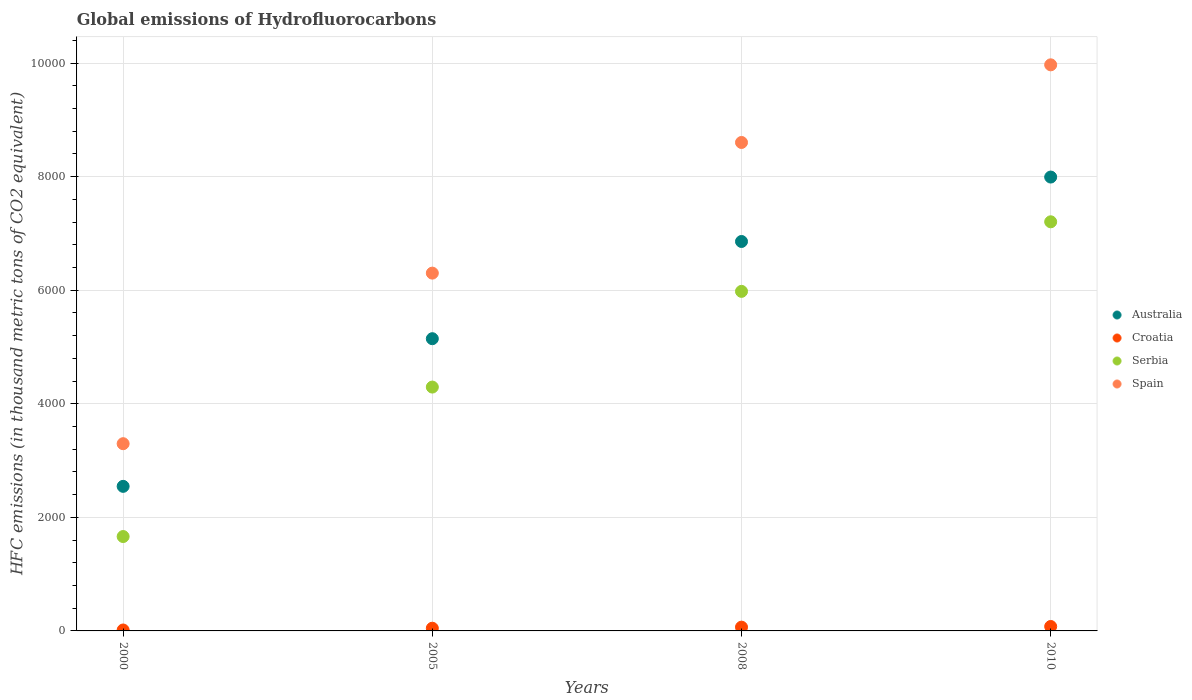Is the number of dotlines equal to the number of legend labels?
Your answer should be compact. Yes. Across all years, what is the minimum global emissions of Hydrofluorocarbons in Spain?
Make the answer very short. 3296.8. In which year was the global emissions of Hydrofluorocarbons in Spain maximum?
Ensure brevity in your answer.  2010. In which year was the global emissions of Hydrofluorocarbons in Croatia minimum?
Keep it short and to the point. 2000. What is the total global emissions of Hydrofluorocarbons in Australia in the graph?
Offer a terse response. 2.25e+04. What is the difference between the global emissions of Hydrofluorocarbons in Spain in 2000 and that in 2010?
Make the answer very short. -6671.2. What is the difference between the global emissions of Hydrofluorocarbons in Serbia in 2000 and the global emissions of Hydrofluorocarbons in Croatia in 2005?
Offer a very short reply. 1614.5. What is the average global emissions of Hydrofluorocarbons in Croatia per year?
Provide a short and direct response. 52.02. In the year 2000, what is the difference between the global emissions of Hydrofluorocarbons in Australia and global emissions of Hydrofluorocarbons in Croatia?
Offer a very short reply. 2529.4. In how many years, is the global emissions of Hydrofluorocarbons in Spain greater than 2400 thousand metric tons?
Give a very brief answer. 4. What is the ratio of the global emissions of Hydrofluorocarbons in Australia in 2008 to that in 2010?
Give a very brief answer. 0.86. Is the difference between the global emissions of Hydrofluorocarbons in Australia in 2008 and 2010 greater than the difference between the global emissions of Hydrofluorocarbons in Croatia in 2008 and 2010?
Your response must be concise. No. What is the difference between the highest and the second highest global emissions of Hydrofluorocarbons in Croatia?
Your answer should be compact. 11.7. What is the difference between the highest and the lowest global emissions of Hydrofluorocarbons in Serbia?
Provide a short and direct response. 5542. In how many years, is the global emissions of Hydrofluorocarbons in Croatia greater than the average global emissions of Hydrofluorocarbons in Croatia taken over all years?
Provide a short and direct response. 2. Is the sum of the global emissions of Hydrofluorocarbons in Australia in 2005 and 2008 greater than the maximum global emissions of Hydrofluorocarbons in Croatia across all years?
Your response must be concise. Yes. Is it the case that in every year, the sum of the global emissions of Hydrofluorocarbons in Serbia and global emissions of Hydrofluorocarbons in Spain  is greater than the sum of global emissions of Hydrofluorocarbons in Croatia and global emissions of Hydrofluorocarbons in Australia?
Your answer should be compact. Yes. Is the global emissions of Hydrofluorocarbons in Serbia strictly less than the global emissions of Hydrofluorocarbons in Croatia over the years?
Your response must be concise. No. How many years are there in the graph?
Your response must be concise. 4. Are the values on the major ticks of Y-axis written in scientific E-notation?
Give a very brief answer. No. Does the graph contain grids?
Your answer should be compact. Yes. How many legend labels are there?
Offer a terse response. 4. How are the legend labels stacked?
Provide a short and direct response. Vertical. What is the title of the graph?
Provide a short and direct response. Global emissions of Hydrofluorocarbons. Does "Libya" appear as one of the legend labels in the graph?
Your answer should be compact. No. What is the label or title of the X-axis?
Provide a short and direct response. Years. What is the label or title of the Y-axis?
Give a very brief answer. HFC emissions (in thousand metric tons of CO2 equivalent). What is the HFC emissions (in thousand metric tons of CO2 equivalent) of Australia in 2000?
Give a very brief answer. 2545.7. What is the HFC emissions (in thousand metric tons of CO2 equivalent) of Serbia in 2000?
Keep it short and to the point. 1662. What is the HFC emissions (in thousand metric tons of CO2 equivalent) in Spain in 2000?
Your answer should be very brief. 3296.8. What is the HFC emissions (in thousand metric tons of CO2 equivalent) of Australia in 2005?
Make the answer very short. 5145.6. What is the HFC emissions (in thousand metric tons of CO2 equivalent) of Croatia in 2005?
Provide a succinct answer. 47.5. What is the HFC emissions (in thousand metric tons of CO2 equivalent) in Serbia in 2005?
Give a very brief answer. 4293.8. What is the HFC emissions (in thousand metric tons of CO2 equivalent) of Spain in 2005?
Provide a succinct answer. 6300.3. What is the HFC emissions (in thousand metric tons of CO2 equivalent) in Australia in 2008?
Provide a short and direct response. 6857.4. What is the HFC emissions (in thousand metric tons of CO2 equivalent) of Croatia in 2008?
Your answer should be compact. 66.3. What is the HFC emissions (in thousand metric tons of CO2 equivalent) of Serbia in 2008?
Your answer should be compact. 5979. What is the HFC emissions (in thousand metric tons of CO2 equivalent) in Spain in 2008?
Your answer should be compact. 8600.9. What is the HFC emissions (in thousand metric tons of CO2 equivalent) in Australia in 2010?
Ensure brevity in your answer.  7992. What is the HFC emissions (in thousand metric tons of CO2 equivalent) of Croatia in 2010?
Make the answer very short. 78. What is the HFC emissions (in thousand metric tons of CO2 equivalent) of Serbia in 2010?
Your answer should be compact. 7204. What is the HFC emissions (in thousand metric tons of CO2 equivalent) of Spain in 2010?
Offer a terse response. 9968. Across all years, what is the maximum HFC emissions (in thousand metric tons of CO2 equivalent) in Australia?
Keep it short and to the point. 7992. Across all years, what is the maximum HFC emissions (in thousand metric tons of CO2 equivalent) in Croatia?
Offer a terse response. 78. Across all years, what is the maximum HFC emissions (in thousand metric tons of CO2 equivalent) of Serbia?
Offer a very short reply. 7204. Across all years, what is the maximum HFC emissions (in thousand metric tons of CO2 equivalent) of Spain?
Provide a succinct answer. 9968. Across all years, what is the minimum HFC emissions (in thousand metric tons of CO2 equivalent) in Australia?
Your response must be concise. 2545.7. Across all years, what is the minimum HFC emissions (in thousand metric tons of CO2 equivalent) in Croatia?
Make the answer very short. 16.3. Across all years, what is the minimum HFC emissions (in thousand metric tons of CO2 equivalent) of Serbia?
Your response must be concise. 1662. Across all years, what is the minimum HFC emissions (in thousand metric tons of CO2 equivalent) of Spain?
Your answer should be very brief. 3296.8. What is the total HFC emissions (in thousand metric tons of CO2 equivalent) of Australia in the graph?
Ensure brevity in your answer.  2.25e+04. What is the total HFC emissions (in thousand metric tons of CO2 equivalent) of Croatia in the graph?
Offer a terse response. 208.1. What is the total HFC emissions (in thousand metric tons of CO2 equivalent) of Serbia in the graph?
Make the answer very short. 1.91e+04. What is the total HFC emissions (in thousand metric tons of CO2 equivalent) of Spain in the graph?
Provide a succinct answer. 2.82e+04. What is the difference between the HFC emissions (in thousand metric tons of CO2 equivalent) in Australia in 2000 and that in 2005?
Make the answer very short. -2599.9. What is the difference between the HFC emissions (in thousand metric tons of CO2 equivalent) of Croatia in 2000 and that in 2005?
Your response must be concise. -31.2. What is the difference between the HFC emissions (in thousand metric tons of CO2 equivalent) of Serbia in 2000 and that in 2005?
Offer a terse response. -2631.8. What is the difference between the HFC emissions (in thousand metric tons of CO2 equivalent) in Spain in 2000 and that in 2005?
Offer a very short reply. -3003.5. What is the difference between the HFC emissions (in thousand metric tons of CO2 equivalent) in Australia in 2000 and that in 2008?
Make the answer very short. -4311.7. What is the difference between the HFC emissions (in thousand metric tons of CO2 equivalent) of Serbia in 2000 and that in 2008?
Your answer should be very brief. -4317. What is the difference between the HFC emissions (in thousand metric tons of CO2 equivalent) of Spain in 2000 and that in 2008?
Make the answer very short. -5304.1. What is the difference between the HFC emissions (in thousand metric tons of CO2 equivalent) in Australia in 2000 and that in 2010?
Keep it short and to the point. -5446.3. What is the difference between the HFC emissions (in thousand metric tons of CO2 equivalent) in Croatia in 2000 and that in 2010?
Provide a succinct answer. -61.7. What is the difference between the HFC emissions (in thousand metric tons of CO2 equivalent) of Serbia in 2000 and that in 2010?
Make the answer very short. -5542. What is the difference between the HFC emissions (in thousand metric tons of CO2 equivalent) in Spain in 2000 and that in 2010?
Keep it short and to the point. -6671.2. What is the difference between the HFC emissions (in thousand metric tons of CO2 equivalent) of Australia in 2005 and that in 2008?
Offer a terse response. -1711.8. What is the difference between the HFC emissions (in thousand metric tons of CO2 equivalent) of Croatia in 2005 and that in 2008?
Give a very brief answer. -18.8. What is the difference between the HFC emissions (in thousand metric tons of CO2 equivalent) in Serbia in 2005 and that in 2008?
Provide a short and direct response. -1685.2. What is the difference between the HFC emissions (in thousand metric tons of CO2 equivalent) in Spain in 2005 and that in 2008?
Provide a succinct answer. -2300.6. What is the difference between the HFC emissions (in thousand metric tons of CO2 equivalent) of Australia in 2005 and that in 2010?
Keep it short and to the point. -2846.4. What is the difference between the HFC emissions (in thousand metric tons of CO2 equivalent) of Croatia in 2005 and that in 2010?
Offer a terse response. -30.5. What is the difference between the HFC emissions (in thousand metric tons of CO2 equivalent) in Serbia in 2005 and that in 2010?
Provide a succinct answer. -2910.2. What is the difference between the HFC emissions (in thousand metric tons of CO2 equivalent) of Spain in 2005 and that in 2010?
Your answer should be compact. -3667.7. What is the difference between the HFC emissions (in thousand metric tons of CO2 equivalent) of Australia in 2008 and that in 2010?
Offer a terse response. -1134.6. What is the difference between the HFC emissions (in thousand metric tons of CO2 equivalent) of Croatia in 2008 and that in 2010?
Your answer should be compact. -11.7. What is the difference between the HFC emissions (in thousand metric tons of CO2 equivalent) of Serbia in 2008 and that in 2010?
Give a very brief answer. -1225. What is the difference between the HFC emissions (in thousand metric tons of CO2 equivalent) of Spain in 2008 and that in 2010?
Keep it short and to the point. -1367.1. What is the difference between the HFC emissions (in thousand metric tons of CO2 equivalent) in Australia in 2000 and the HFC emissions (in thousand metric tons of CO2 equivalent) in Croatia in 2005?
Keep it short and to the point. 2498.2. What is the difference between the HFC emissions (in thousand metric tons of CO2 equivalent) of Australia in 2000 and the HFC emissions (in thousand metric tons of CO2 equivalent) of Serbia in 2005?
Give a very brief answer. -1748.1. What is the difference between the HFC emissions (in thousand metric tons of CO2 equivalent) in Australia in 2000 and the HFC emissions (in thousand metric tons of CO2 equivalent) in Spain in 2005?
Provide a short and direct response. -3754.6. What is the difference between the HFC emissions (in thousand metric tons of CO2 equivalent) of Croatia in 2000 and the HFC emissions (in thousand metric tons of CO2 equivalent) of Serbia in 2005?
Your response must be concise. -4277.5. What is the difference between the HFC emissions (in thousand metric tons of CO2 equivalent) in Croatia in 2000 and the HFC emissions (in thousand metric tons of CO2 equivalent) in Spain in 2005?
Your response must be concise. -6284. What is the difference between the HFC emissions (in thousand metric tons of CO2 equivalent) in Serbia in 2000 and the HFC emissions (in thousand metric tons of CO2 equivalent) in Spain in 2005?
Keep it short and to the point. -4638.3. What is the difference between the HFC emissions (in thousand metric tons of CO2 equivalent) in Australia in 2000 and the HFC emissions (in thousand metric tons of CO2 equivalent) in Croatia in 2008?
Offer a terse response. 2479.4. What is the difference between the HFC emissions (in thousand metric tons of CO2 equivalent) in Australia in 2000 and the HFC emissions (in thousand metric tons of CO2 equivalent) in Serbia in 2008?
Make the answer very short. -3433.3. What is the difference between the HFC emissions (in thousand metric tons of CO2 equivalent) in Australia in 2000 and the HFC emissions (in thousand metric tons of CO2 equivalent) in Spain in 2008?
Give a very brief answer. -6055.2. What is the difference between the HFC emissions (in thousand metric tons of CO2 equivalent) in Croatia in 2000 and the HFC emissions (in thousand metric tons of CO2 equivalent) in Serbia in 2008?
Give a very brief answer. -5962.7. What is the difference between the HFC emissions (in thousand metric tons of CO2 equivalent) of Croatia in 2000 and the HFC emissions (in thousand metric tons of CO2 equivalent) of Spain in 2008?
Ensure brevity in your answer.  -8584.6. What is the difference between the HFC emissions (in thousand metric tons of CO2 equivalent) in Serbia in 2000 and the HFC emissions (in thousand metric tons of CO2 equivalent) in Spain in 2008?
Ensure brevity in your answer.  -6938.9. What is the difference between the HFC emissions (in thousand metric tons of CO2 equivalent) in Australia in 2000 and the HFC emissions (in thousand metric tons of CO2 equivalent) in Croatia in 2010?
Provide a succinct answer. 2467.7. What is the difference between the HFC emissions (in thousand metric tons of CO2 equivalent) of Australia in 2000 and the HFC emissions (in thousand metric tons of CO2 equivalent) of Serbia in 2010?
Offer a terse response. -4658.3. What is the difference between the HFC emissions (in thousand metric tons of CO2 equivalent) in Australia in 2000 and the HFC emissions (in thousand metric tons of CO2 equivalent) in Spain in 2010?
Your answer should be very brief. -7422.3. What is the difference between the HFC emissions (in thousand metric tons of CO2 equivalent) in Croatia in 2000 and the HFC emissions (in thousand metric tons of CO2 equivalent) in Serbia in 2010?
Make the answer very short. -7187.7. What is the difference between the HFC emissions (in thousand metric tons of CO2 equivalent) in Croatia in 2000 and the HFC emissions (in thousand metric tons of CO2 equivalent) in Spain in 2010?
Make the answer very short. -9951.7. What is the difference between the HFC emissions (in thousand metric tons of CO2 equivalent) in Serbia in 2000 and the HFC emissions (in thousand metric tons of CO2 equivalent) in Spain in 2010?
Your answer should be very brief. -8306. What is the difference between the HFC emissions (in thousand metric tons of CO2 equivalent) in Australia in 2005 and the HFC emissions (in thousand metric tons of CO2 equivalent) in Croatia in 2008?
Ensure brevity in your answer.  5079.3. What is the difference between the HFC emissions (in thousand metric tons of CO2 equivalent) of Australia in 2005 and the HFC emissions (in thousand metric tons of CO2 equivalent) of Serbia in 2008?
Your answer should be compact. -833.4. What is the difference between the HFC emissions (in thousand metric tons of CO2 equivalent) of Australia in 2005 and the HFC emissions (in thousand metric tons of CO2 equivalent) of Spain in 2008?
Offer a very short reply. -3455.3. What is the difference between the HFC emissions (in thousand metric tons of CO2 equivalent) of Croatia in 2005 and the HFC emissions (in thousand metric tons of CO2 equivalent) of Serbia in 2008?
Make the answer very short. -5931.5. What is the difference between the HFC emissions (in thousand metric tons of CO2 equivalent) of Croatia in 2005 and the HFC emissions (in thousand metric tons of CO2 equivalent) of Spain in 2008?
Offer a very short reply. -8553.4. What is the difference between the HFC emissions (in thousand metric tons of CO2 equivalent) of Serbia in 2005 and the HFC emissions (in thousand metric tons of CO2 equivalent) of Spain in 2008?
Ensure brevity in your answer.  -4307.1. What is the difference between the HFC emissions (in thousand metric tons of CO2 equivalent) of Australia in 2005 and the HFC emissions (in thousand metric tons of CO2 equivalent) of Croatia in 2010?
Provide a succinct answer. 5067.6. What is the difference between the HFC emissions (in thousand metric tons of CO2 equivalent) of Australia in 2005 and the HFC emissions (in thousand metric tons of CO2 equivalent) of Serbia in 2010?
Provide a short and direct response. -2058.4. What is the difference between the HFC emissions (in thousand metric tons of CO2 equivalent) in Australia in 2005 and the HFC emissions (in thousand metric tons of CO2 equivalent) in Spain in 2010?
Your response must be concise. -4822.4. What is the difference between the HFC emissions (in thousand metric tons of CO2 equivalent) in Croatia in 2005 and the HFC emissions (in thousand metric tons of CO2 equivalent) in Serbia in 2010?
Your response must be concise. -7156.5. What is the difference between the HFC emissions (in thousand metric tons of CO2 equivalent) in Croatia in 2005 and the HFC emissions (in thousand metric tons of CO2 equivalent) in Spain in 2010?
Offer a terse response. -9920.5. What is the difference between the HFC emissions (in thousand metric tons of CO2 equivalent) in Serbia in 2005 and the HFC emissions (in thousand metric tons of CO2 equivalent) in Spain in 2010?
Give a very brief answer. -5674.2. What is the difference between the HFC emissions (in thousand metric tons of CO2 equivalent) of Australia in 2008 and the HFC emissions (in thousand metric tons of CO2 equivalent) of Croatia in 2010?
Offer a very short reply. 6779.4. What is the difference between the HFC emissions (in thousand metric tons of CO2 equivalent) of Australia in 2008 and the HFC emissions (in thousand metric tons of CO2 equivalent) of Serbia in 2010?
Ensure brevity in your answer.  -346.6. What is the difference between the HFC emissions (in thousand metric tons of CO2 equivalent) of Australia in 2008 and the HFC emissions (in thousand metric tons of CO2 equivalent) of Spain in 2010?
Your answer should be very brief. -3110.6. What is the difference between the HFC emissions (in thousand metric tons of CO2 equivalent) of Croatia in 2008 and the HFC emissions (in thousand metric tons of CO2 equivalent) of Serbia in 2010?
Your answer should be compact. -7137.7. What is the difference between the HFC emissions (in thousand metric tons of CO2 equivalent) of Croatia in 2008 and the HFC emissions (in thousand metric tons of CO2 equivalent) of Spain in 2010?
Provide a succinct answer. -9901.7. What is the difference between the HFC emissions (in thousand metric tons of CO2 equivalent) of Serbia in 2008 and the HFC emissions (in thousand metric tons of CO2 equivalent) of Spain in 2010?
Give a very brief answer. -3989. What is the average HFC emissions (in thousand metric tons of CO2 equivalent) in Australia per year?
Offer a very short reply. 5635.18. What is the average HFC emissions (in thousand metric tons of CO2 equivalent) of Croatia per year?
Your response must be concise. 52.02. What is the average HFC emissions (in thousand metric tons of CO2 equivalent) of Serbia per year?
Your answer should be very brief. 4784.7. What is the average HFC emissions (in thousand metric tons of CO2 equivalent) of Spain per year?
Provide a short and direct response. 7041.5. In the year 2000, what is the difference between the HFC emissions (in thousand metric tons of CO2 equivalent) in Australia and HFC emissions (in thousand metric tons of CO2 equivalent) in Croatia?
Your answer should be very brief. 2529.4. In the year 2000, what is the difference between the HFC emissions (in thousand metric tons of CO2 equivalent) in Australia and HFC emissions (in thousand metric tons of CO2 equivalent) in Serbia?
Provide a short and direct response. 883.7. In the year 2000, what is the difference between the HFC emissions (in thousand metric tons of CO2 equivalent) of Australia and HFC emissions (in thousand metric tons of CO2 equivalent) of Spain?
Provide a succinct answer. -751.1. In the year 2000, what is the difference between the HFC emissions (in thousand metric tons of CO2 equivalent) of Croatia and HFC emissions (in thousand metric tons of CO2 equivalent) of Serbia?
Provide a succinct answer. -1645.7. In the year 2000, what is the difference between the HFC emissions (in thousand metric tons of CO2 equivalent) of Croatia and HFC emissions (in thousand metric tons of CO2 equivalent) of Spain?
Your response must be concise. -3280.5. In the year 2000, what is the difference between the HFC emissions (in thousand metric tons of CO2 equivalent) of Serbia and HFC emissions (in thousand metric tons of CO2 equivalent) of Spain?
Make the answer very short. -1634.8. In the year 2005, what is the difference between the HFC emissions (in thousand metric tons of CO2 equivalent) of Australia and HFC emissions (in thousand metric tons of CO2 equivalent) of Croatia?
Provide a succinct answer. 5098.1. In the year 2005, what is the difference between the HFC emissions (in thousand metric tons of CO2 equivalent) in Australia and HFC emissions (in thousand metric tons of CO2 equivalent) in Serbia?
Make the answer very short. 851.8. In the year 2005, what is the difference between the HFC emissions (in thousand metric tons of CO2 equivalent) in Australia and HFC emissions (in thousand metric tons of CO2 equivalent) in Spain?
Make the answer very short. -1154.7. In the year 2005, what is the difference between the HFC emissions (in thousand metric tons of CO2 equivalent) of Croatia and HFC emissions (in thousand metric tons of CO2 equivalent) of Serbia?
Provide a short and direct response. -4246.3. In the year 2005, what is the difference between the HFC emissions (in thousand metric tons of CO2 equivalent) of Croatia and HFC emissions (in thousand metric tons of CO2 equivalent) of Spain?
Your answer should be very brief. -6252.8. In the year 2005, what is the difference between the HFC emissions (in thousand metric tons of CO2 equivalent) of Serbia and HFC emissions (in thousand metric tons of CO2 equivalent) of Spain?
Offer a very short reply. -2006.5. In the year 2008, what is the difference between the HFC emissions (in thousand metric tons of CO2 equivalent) in Australia and HFC emissions (in thousand metric tons of CO2 equivalent) in Croatia?
Make the answer very short. 6791.1. In the year 2008, what is the difference between the HFC emissions (in thousand metric tons of CO2 equivalent) of Australia and HFC emissions (in thousand metric tons of CO2 equivalent) of Serbia?
Your response must be concise. 878.4. In the year 2008, what is the difference between the HFC emissions (in thousand metric tons of CO2 equivalent) of Australia and HFC emissions (in thousand metric tons of CO2 equivalent) of Spain?
Ensure brevity in your answer.  -1743.5. In the year 2008, what is the difference between the HFC emissions (in thousand metric tons of CO2 equivalent) in Croatia and HFC emissions (in thousand metric tons of CO2 equivalent) in Serbia?
Ensure brevity in your answer.  -5912.7. In the year 2008, what is the difference between the HFC emissions (in thousand metric tons of CO2 equivalent) of Croatia and HFC emissions (in thousand metric tons of CO2 equivalent) of Spain?
Your response must be concise. -8534.6. In the year 2008, what is the difference between the HFC emissions (in thousand metric tons of CO2 equivalent) of Serbia and HFC emissions (in thousand metric tons of CO2 equivalent) of Spain?
Provide a short and direct response. -2621.9. In the year 2010, what is the difference between the HFC emissions (in thousand metric tons of CO2 equivalent) of Australia and HFC emissions (in thousand metric tons of CO2 equivalent) of Croatia?
Provide a short and direct response. 7914. In the year 2010, what is the difference between the HFC emissions (in thousand metric tons of CO2 equivalent) of Australia and HFC emissions (in thousand metric tons of CO2 equivalent) of Serbia?
Offer a very short reply. 788. In the year 2010, what is the difference between the HFC emissions (in thousand metric tons of CO2 equivalent) of Australia and HFC emissions (in thousand metric tons of CO2 equivalent) of Spain?
Your answer should be very brief. -1976. In the year 2010, what is the difference between the HFC emissions (in thousand metric tons of CO2 equivalent) in Croatia and HFC emissions (in thousand metric tons of CO2 equivalent) in Serbia?
Your response must be concise. -7126. In the year 2010, what is the difference between the HFC emissions (in thousand metric tons of CO2 equivalent) in Croatia and HFC emissions (in thousand metric tons of CO2 equivalent) in Spain?
Your answer should be compact. -9890. In the year 2010, what is the difference between the HFC emissions (in thousand metric tons of CO2 equivalent) in Serbia and HFC emissions (in thousand metric tons of CO2 equivalent) in Spain?
Provide a succinct answer. -2764. What is the ratio of the HFC emissions (in thousand metric tons of CO2 equivalent) of Australia in 2000 to that in 2005?
Ensure brevity in your answer.  0.49. What is the ratio of the HFC emissions (in thousand metric tons of CO2 equivalent) of Croatia in 2000 to that in 2005?
Your answer should be very brief. 0.34. What is the ratio of the HFC emissions (in thousand metric tons of CO2 equivalent) in Serbia in 2000 to that in 2005?
Provide a short and direct response. 0.39. What is the ratio of the HFC emissions (in thousand metric tons of CO2 equivalent) of Spain in 2000 to that in 2005?
Your answer should be compact. 0.52. What is the ratio of the HFC emissions (in thousand metric tons of CO2 equivalent) of Australia in 2000 to that in 2008?
Your answer should be very brief. 0.37. What is the ratio of the HFC emissions (in thousand metric tons of CO2 equivalent) in Croatia in 2000 to that in 2008?
Provide a short and direct response. 0.25. What is the ratio of the HFC emissions (in thousand metric tons of CO2 equivalent) of Serbia in 2000 to that in 2008?
Ensure brevity in your answer.  0.28. What is the ratio of the HFC emissions (in thousand metric tons of CO2 equivalent) in Spain in 2000 to that in 2008?
Make the answer very short. 0.38. What is the ratio of the HFC emissions (in thousand metric tons of CO2 equivalent) in Australia in 2000 to that in 2010?
Your answer should be compact. 0.32. What is the ratio of the HFC emissions (in thousand metric tons of CO2 equivalent) in Croatia in 2000 to that in 2010?
Keep it short and to the point. 0.21. What is the ratio of the HFC emissions (in thousand metric tons of CO2 equivalent) of Serbia in 2000 to that in 2010?
Make the answer very short. 0.23. What is the ratio of the HFC emissions (in thousand metric tons of CO2 equivalent) in Spain in 2000 to that in 2010?
Offer a terse response. 0.33. What is the ratio of the HFC emissions (in thousand metric tons of CO2 equivalent) in Australia in 2005 to that in 2008?
Your response must be concise. 0.75. What is the ratio of the HFC emissions (in thousand metric tons of CO2 equivalent) in Croatia in 2005 to that in 2008?
Your answer should be very brief. 0.72. What is the ratio of the HFC emissions (in thousand metric tons of CO2 equivalent) of Serbia in 2005 to that in 2008?
Your answer should be compact. 0.72. What is the ratio of the HFC emissions (in thousand metric tons of CO2 equivalent) in Spain in 2005 to that in 2008?
Keep it short and to the point. 0.73. What is the ratio of the HFC emissions (in thousand metric tons of CO2 equivalent) of Australia in 2005 to that in 2010?
Offer a terse response. 0.64. What is the ratio of the HFC emissions (in thousand metric tons of CO2 equivalent) in Croatia in 2005 to that in 2010?
Your response must be concise. 0.61. What is the ratio of the HFC emissions (in thousand metric tons of CO2 equivalent) in Serbia in 2005 to that in 2010?
Ensure brevity in your answer.  0.6. What is the ratio of the HFC emissions (in thousand metric tons of CO2 equivalent) in Spain in 2005 to that in 2010?
Give a very brief answer. 0.63. What is the ratio of the HFC emissions (in thousand metric tons of CO2 equivalent) of Australia in 2008 to that in 2010?
Make the answer very short. 0.86. What is the ratio of the HFC emissions (in thousand metric tons of CO2 equivalent) in Serbia in 2008 to that in 2010?
Provide a succinct answer. 0.83. What is the ratio of the HFC emissions (in thousand metric tons of CO2 equivalent) in Spain in 2008 to that in 2010?
Keep it short and to the point. 0.86. What is the difference between the highest and the second highest HFC emissions (in thousand metric tons of CO2 equivalent) of Australia?
Keep it short and to the point. 1134.6. What is the difference between the highest and the second highest HFC emissions (in thousand metric tons of CO2 equivalent) of Serbia?
Provide a short and direct response. 1225. What is the difference between the highest and the second highest HFC emissions (in thousand metric tons of CO2 equivalent) in Spain?
Your response must be concise. 1367.1. What is the difference between the highest and the lowest HFC emissions (in thousand metric tons of CO2 equivalent) of Australia?
Give a very brief answer. 5446.3. What is the difference between the highest and the lowest HFC emissions (in thousand metric tons of CO2 equivalent) of Croatia?
Offer a terse response. 61.7. What is the difference between the highest and the lowest HFC emissions (in thousand metric tons of CO2 equivalent) in Serbia?
Your answer should be very brief. 5542. What is the difference between the highest and the lowest HFC emissions (in thousand metric tons of CO2 equivalent) of Spain?
Your answer should be compact. 6671.2. 